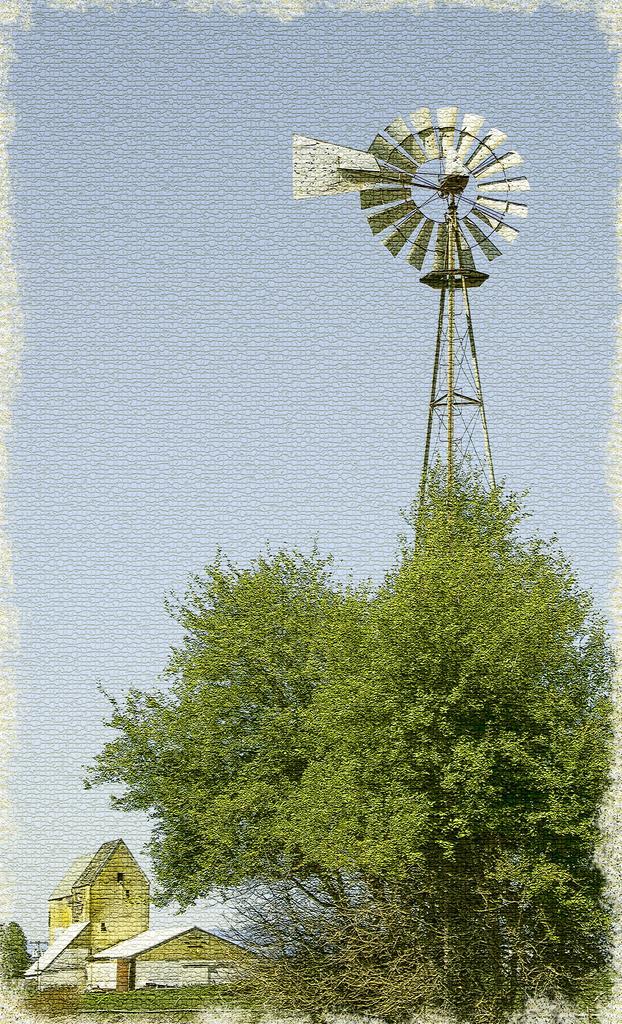Please provide a concise description of this image. In the foreground of this edited image, there is a tree on the right. A wind fan behind it. In the background, there are few houses, greenery and the sky. 